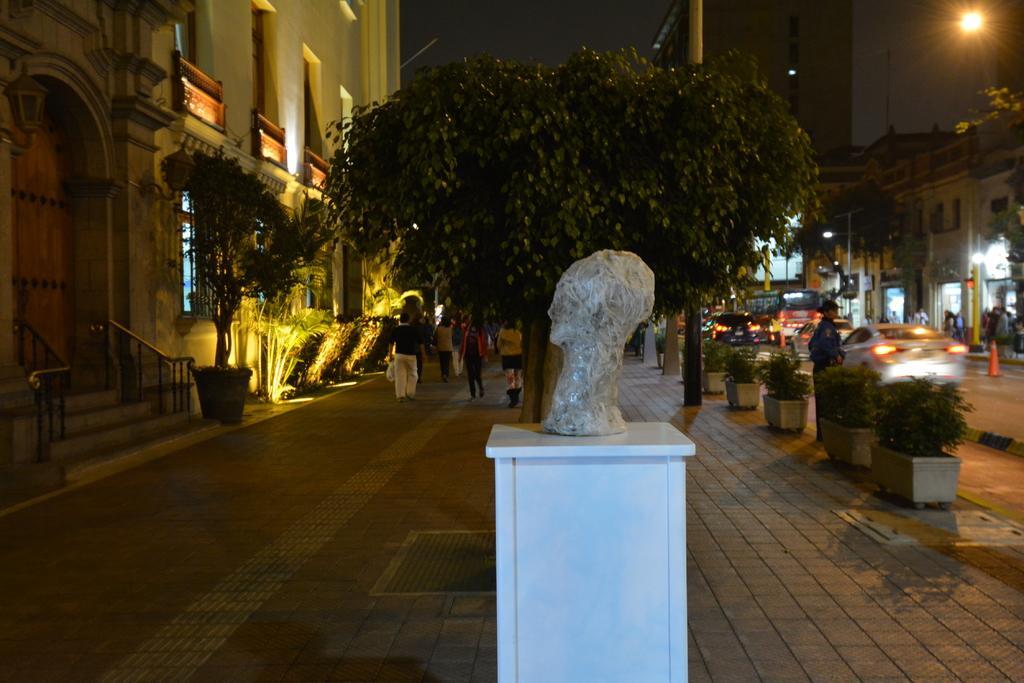Describe this image in one or two sentences. In the middle of the image there is a white pillar with a statue on it. To the left side of the image there is a building with doors, windows, walls and pillars. In front of the door there are steps with railing. And in front of the building there is a footpath with few people are walking and also there are trees. And to the right side on the footpath there are pots with plants. Behind the footpath to the right side there are few vehicles on the road. And to the right corner there are buildings poles with street lights and trees. 